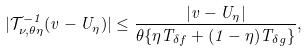Convert formula to latex. <formula><loc_0><loc_0><loc_500><loc_500>| \mathcal { T } _ { \nu , \theta \eta } ^ { - 1 } ( v - U _ { \eta } ) | \leq \frac { | v - U _ { \eta } | } { \theta \{ \eta T _ { \delta f } + ( 1 - \eta ) T _ { \delta g } \} } ,</formula> 